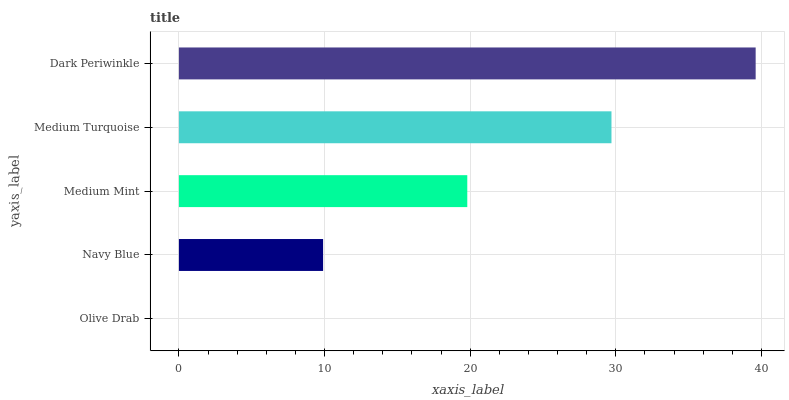Is Olive Drab the minimum?
Answer yes or no. Yes. Is Dark Periwinkle the maximum?
Answer yes or no. Yes. Is Navy Blue the minimum?
Answer yes or no. No. Is Navy Blue the maximum?
Answer yes or no. No. Is Navy Blue greater than Olive Drab?
Answer yes or no. Yes. Is Olive Drab less than Navy Blue?
Answer yes or no. Yes. Is Olive Drab greater than Navy Blue?
Answer yes or no. No. Is Navy Blue less than Olive Drab?
Answer yes or no. No. Is Medium Mint the high median?
Answer yes or no. Yes. Is Medium Mint the low median?
Answer yes or no. Yes. Is Medium Turquoise the high median?
Answer yes or no. No. Is Navy Blue the low median?
Answer yes or no. No. 